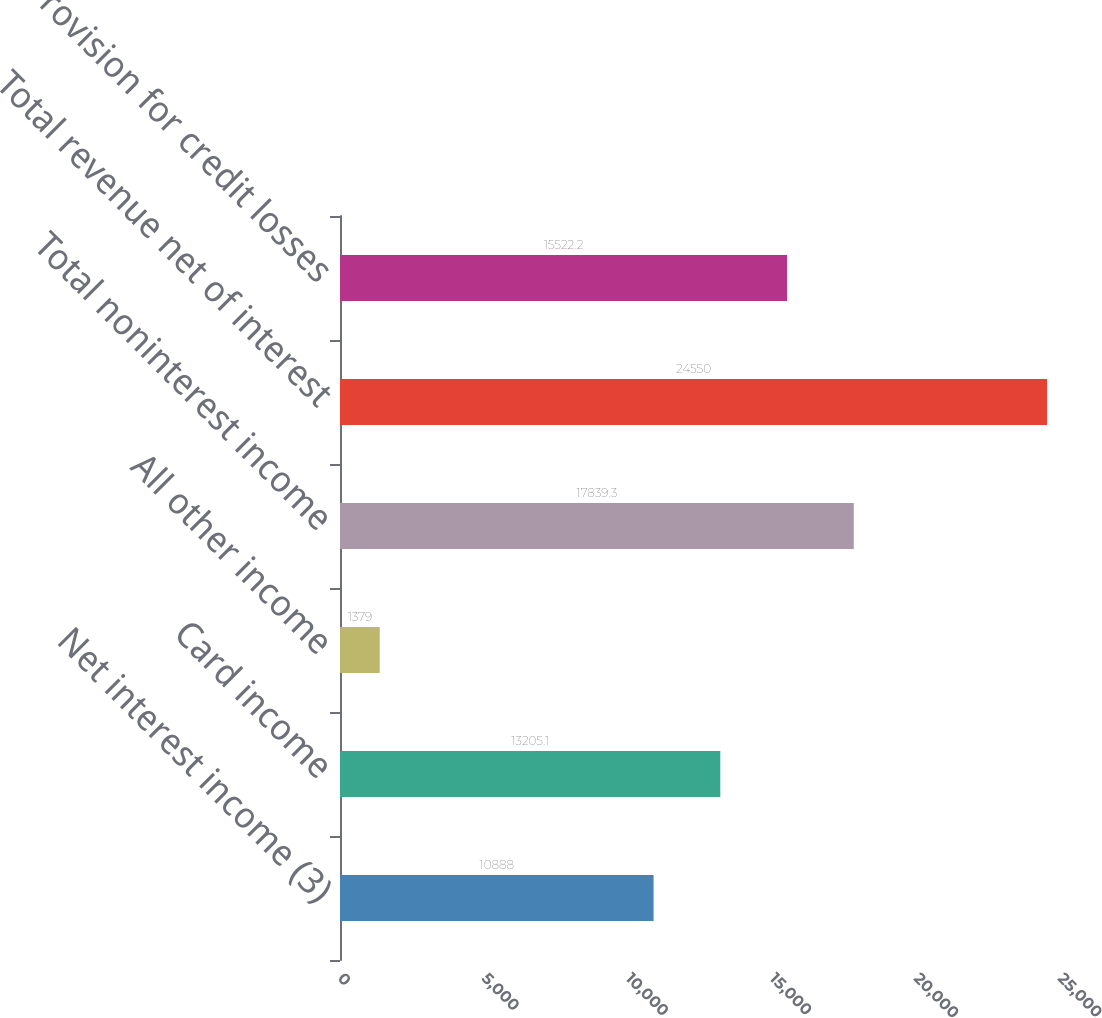Convert chart to OTSL. <chart><loc_0><loc_0><loc_500><loc_500><bar_chart><fcel>Net interest income (3)<fcel>Card income<fcel>All other income<fcel>Total noninterest income<fcel>Total revenue net of interest<fcel>Provision for credit losses<nl><fcel>10888<fcel>13205.1<fcel>1379<fcel>17839.3<fcel>24550<fcel>15522.2<nl></chart> 